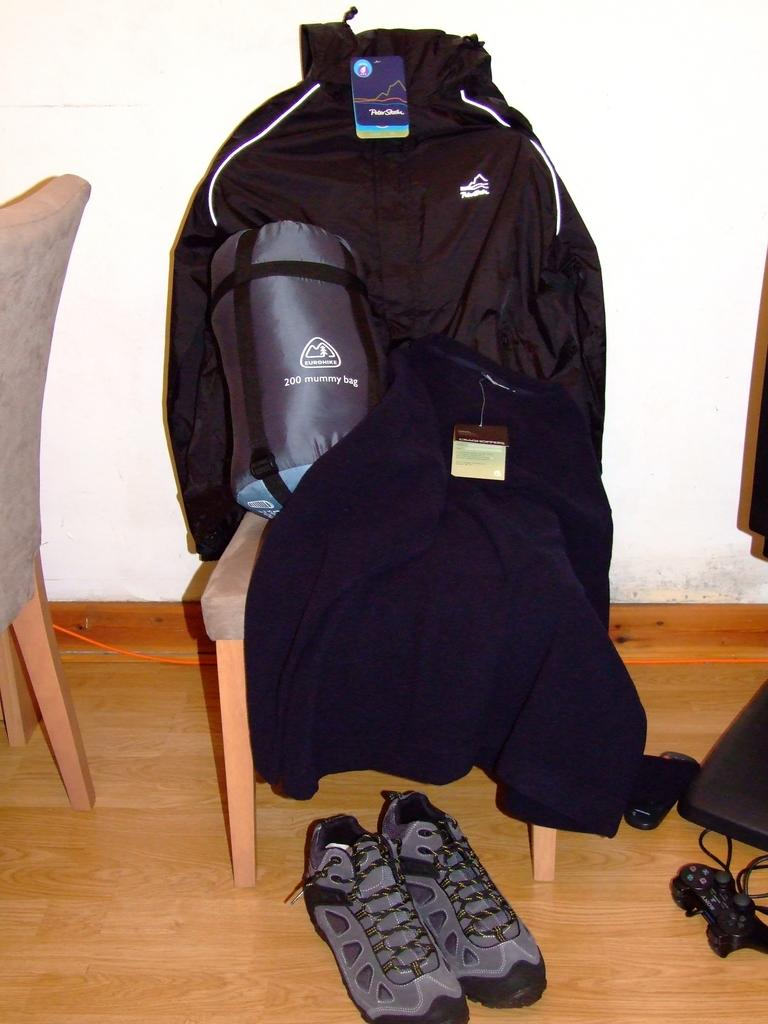What object can be seen in the image that might be used for carrying items? There is a bag in the image that might be used for carrying items. What type of clothing is on the chair in the image? There is a jersey on a chair in the image. What type of footwear is on the floor in the image? There is a shoe on the floor in the image. What type of gaming console is on the left side of the image? There is a play station on the left side of the image. How many fingers are visible on the thumb in the image? There are no fingers or thumbs visible in the image. What type of circle is present in the image? There is no circle present in the image. 